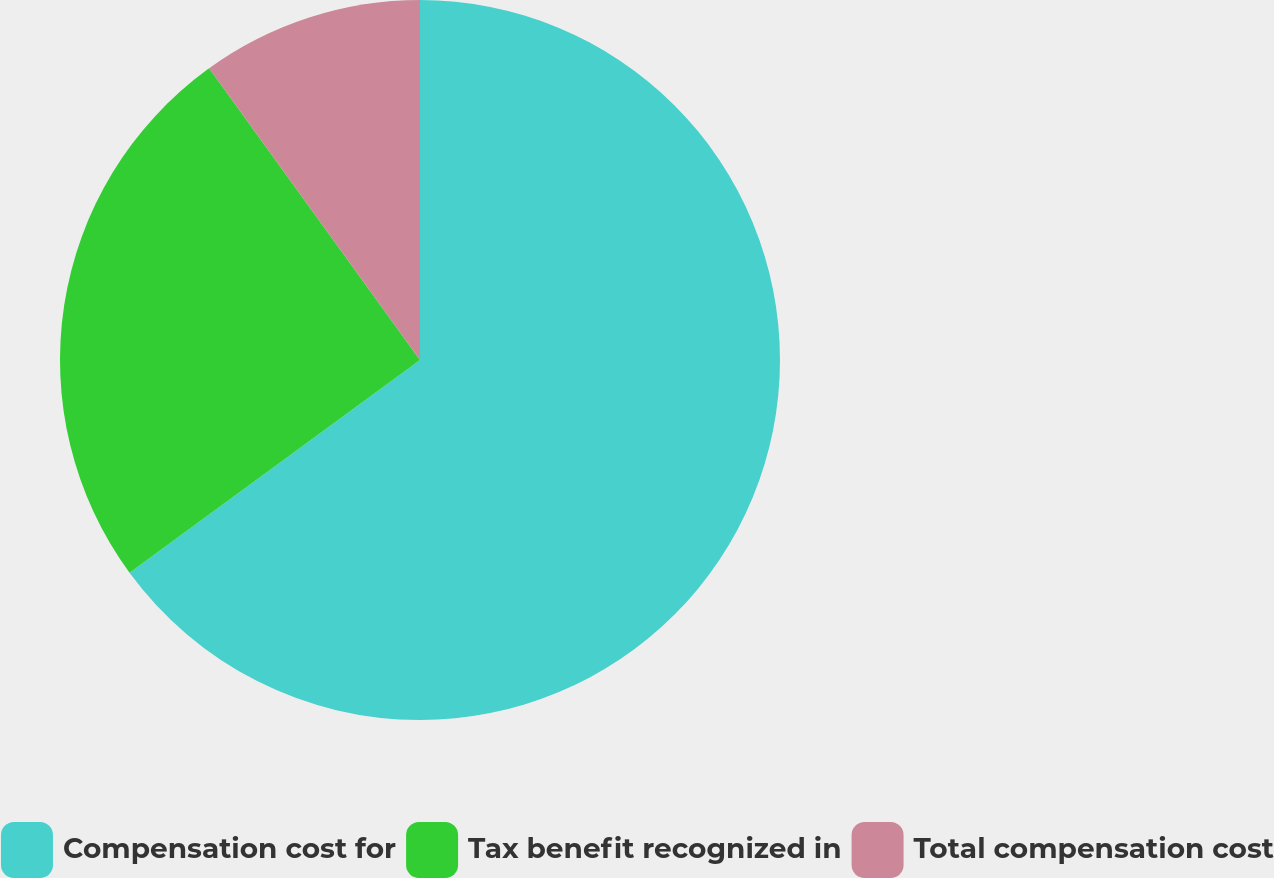Convert chart to OTSL. <chart><loc_0><loc_0><loc_500><loc_500><pie_chart><fcel>Compensation cost for<fcel>Tax benefit recognized in<fcel>Total compensation cost<nl><fcel>64.94%<fcel>25.1%<fcel>9.96%<nl></chart> 